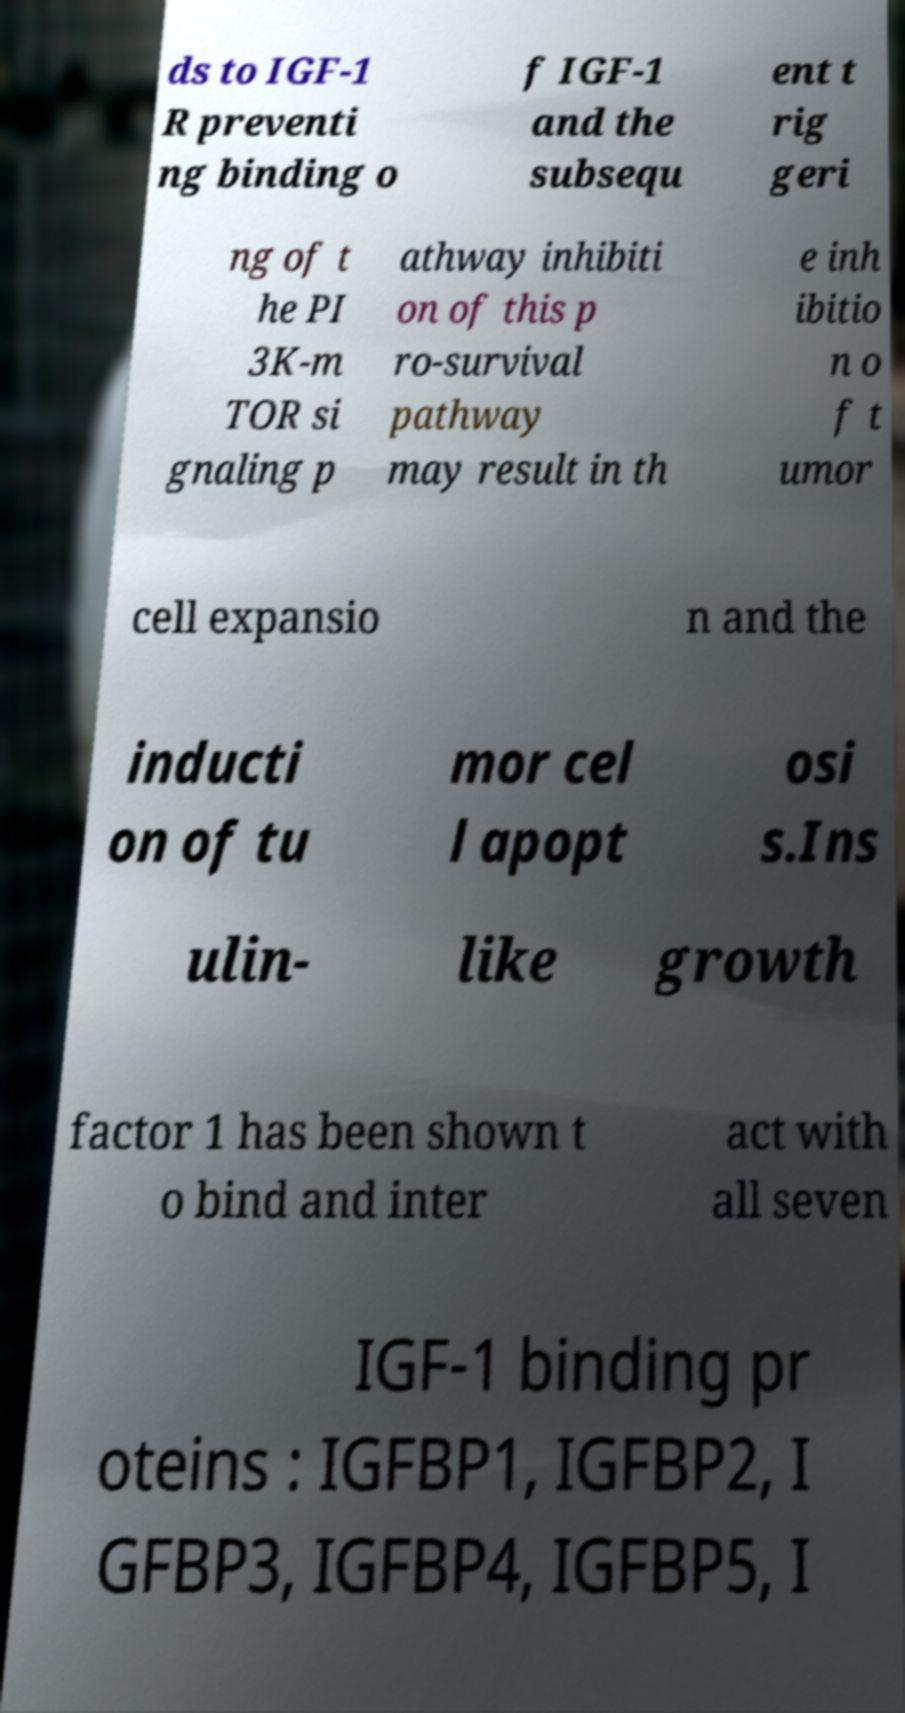Could you assist in decoding the text presented in this image and type it out clearly? ds to IGF-1 R preventi ng binding o f IGF-1 and the subsequ ent t rig geri ng of t he PI 3K-m TOR si gnaling p athway inhibiti on of this p ro-survival pathway may result in th e inh ibitio n o f t umor cell expansio n and the inducti on of tu mor cel l apopt osi s.Ins ulin- like growth factor 1 has been shown t o bind and inter act with all seven IGF-1 binding pr oteins : IGFBP1, IGFBP2, I GFBP3, IGFBP4, IGFBP5, I 